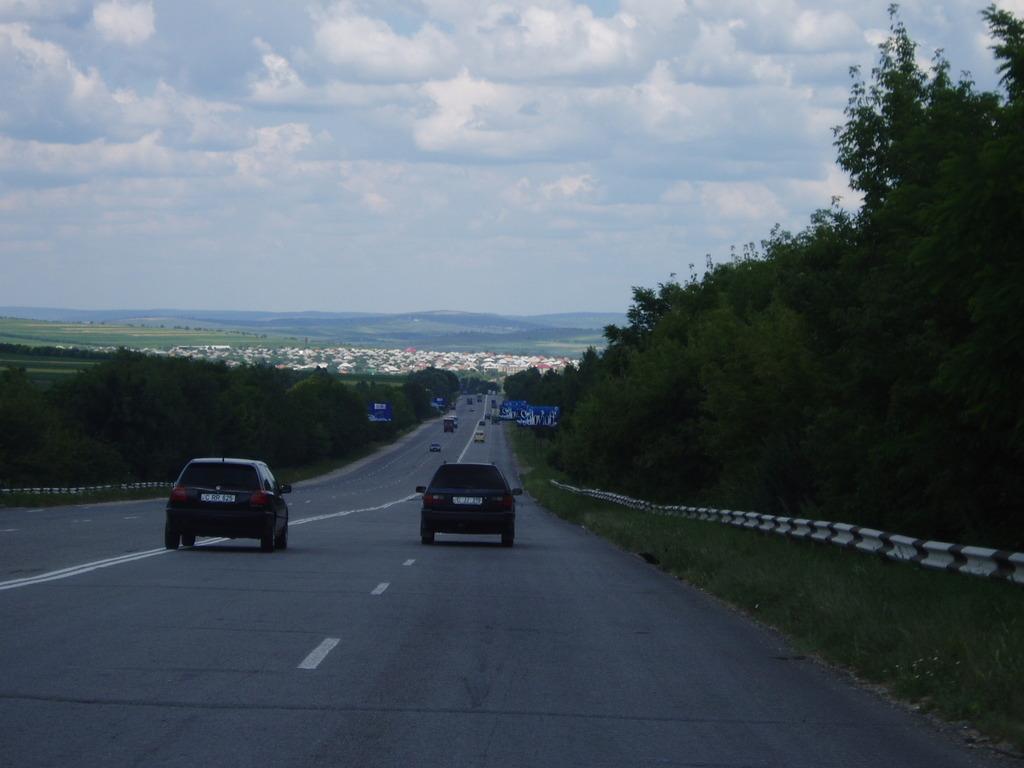Could you give a brief overview of what you see in this image? In this image I can see the road, few vehicles on the road, few trees on both sides of the road, the railing and in the background I can see few buildings and the sky. 